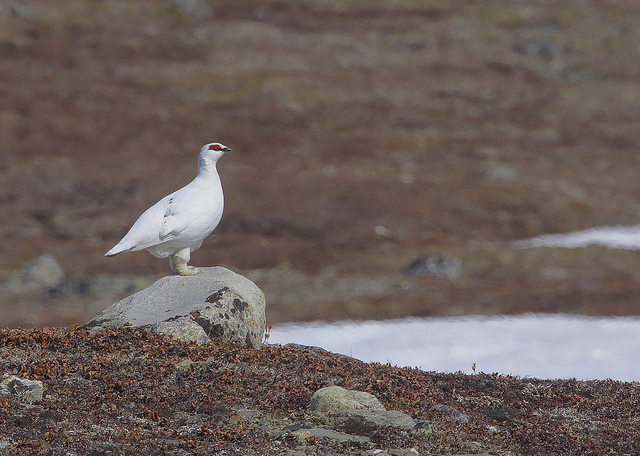<image>What type of bird? I am not sure about the type of bird. It can be a dove, seabird, groull, tern, or seagull. What type of bird? I don't know what type of bird it is. It can be a dove, a seabird, a grouse, or something else. 